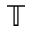<formula> <loc_0><loc_0><loc_500><loc_500>\mathbb { T }</formula> 